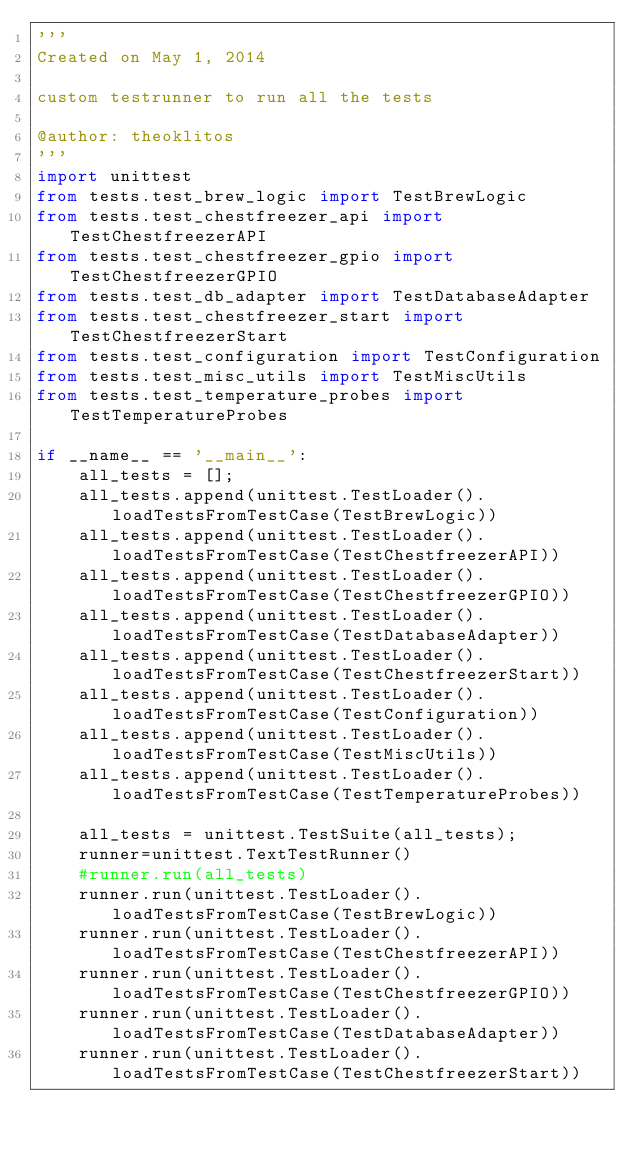Convert code to text. <code><loc_0><loc_0><loc_500><loc_500><_Python_>'''
Created on May 1, 2014

custom testrunner to run all the tests

@author: theoklitos
'''
import unittest
from tests.test_brew_logic import TestBrewLogic
from tests.test_chestfreezer_api import TestChestfreezerAPI
from tests.test_chestfreezer_gpio import TestChestfreezerGPIO
from tests.test_db_adapter import TestDatabaseAdapter
from tests.test_chestfreezer_start import TestChestfreezerStart
from tests.test_configuration import TestConfiguration
from tests.test_misc_utils import TestMiscUtils
from tests.test_temperature_probes import TestTemperatureProbes

if __name__ == '__main__':
    all_tests = [];
    all_tests.append(unittest.TestLoader().loadTestsFromTestCase(TestBrewLogic))
    all_tests.append(unittest.TestLoader().loadTestsFromTestCase(TestChestfreezerAPI))
    all_tests.append(unittest.TestLoader().loadTestsFromTestCase(TestChestfreezerGPIO))
    all_tests.append(unittest.TestLoader().loadTestsFromTestCase(TestDatabaseAdapter))
    all_tests.append(unittest.TestLoader().loadTestsFromTestCase(TestChestfreezerStart))
    all_tests.append(unittest.TestLoader().loadTestsFromTestCase(TestConfiguration))
    all_tests.append(unittest.TestLoader().loadTestsFromTestCase(TestMiscUtils))
    all_tests.append(unittest.TestLoader().loadTestsFromTestCase(TestTemperatureProbes))
    
    all_tests = unittest.TestSuite(all_tests);    
    runner=unittest.TextTestRunner()    
    #runner.run(all_tests)
    runner.run(unittest.TestLoader().loadTestsFromTestCase(TestBrewLogic))
    runner.run(unittest.TestLoader().loadTestsFromTestCase(TestChestfreezerAPI))
    runner.run(unittest.TestLoader().loadTestsFromTestCase(TestChestfreezerGPIO))
    runner.run(unittest.TestLoader().loadTestsFromTestCase(TestDatabaseAdapter))
    runner.run(unittest.TestLoader().loadTestsFromTestCase(TestChestfreezerStart))</code> 